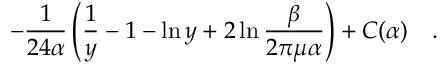Convert formula to latex. <formula><loc_0><loc_0><loc_500><loc_500>- { \frac { 1 } { 2 4 \alpha } } \left ( \frac { 1 } { y } - 1 - \ln y + 2 \ln { \frac { \beta } { 2 \pi \mu \alpha } } \right ) + C ( \alpha ) .</formula> 